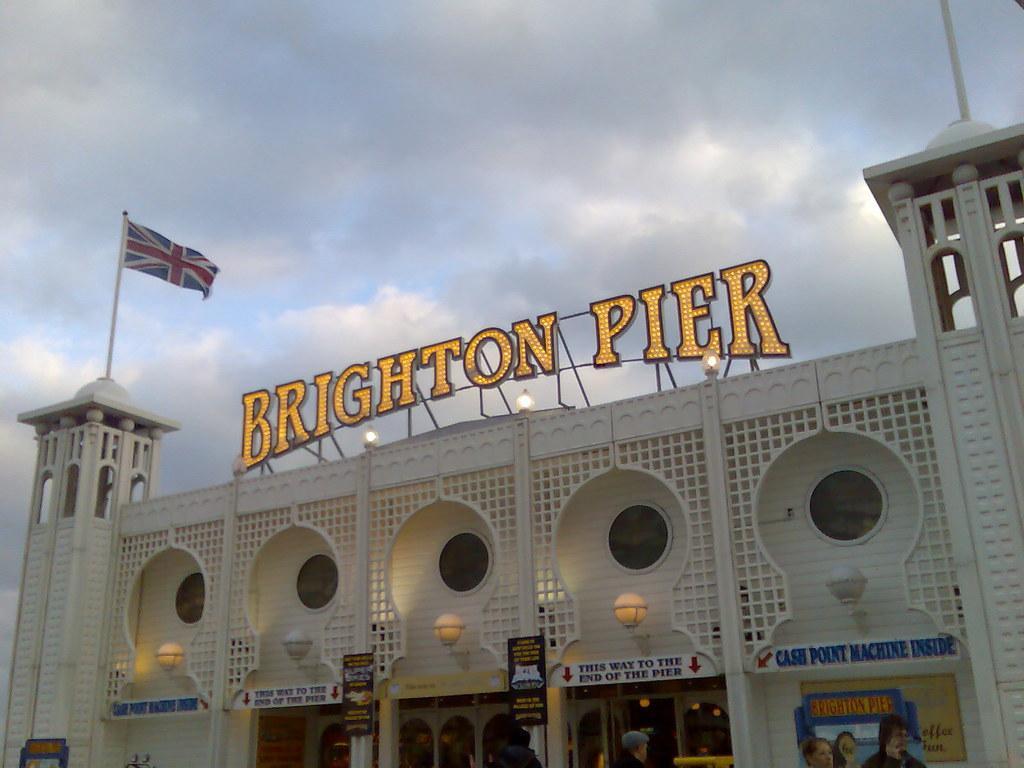In one or two sentences, can you explain what this image depicts? This picture is clicked outside. In the center we can see the building and the text attached to the building with the help of the metal rods and we can see the lamps which are wall mounted and there is a flag and the boards on which the text is printed. In the foreground we can see the group of persons. In the background there is a sky. 